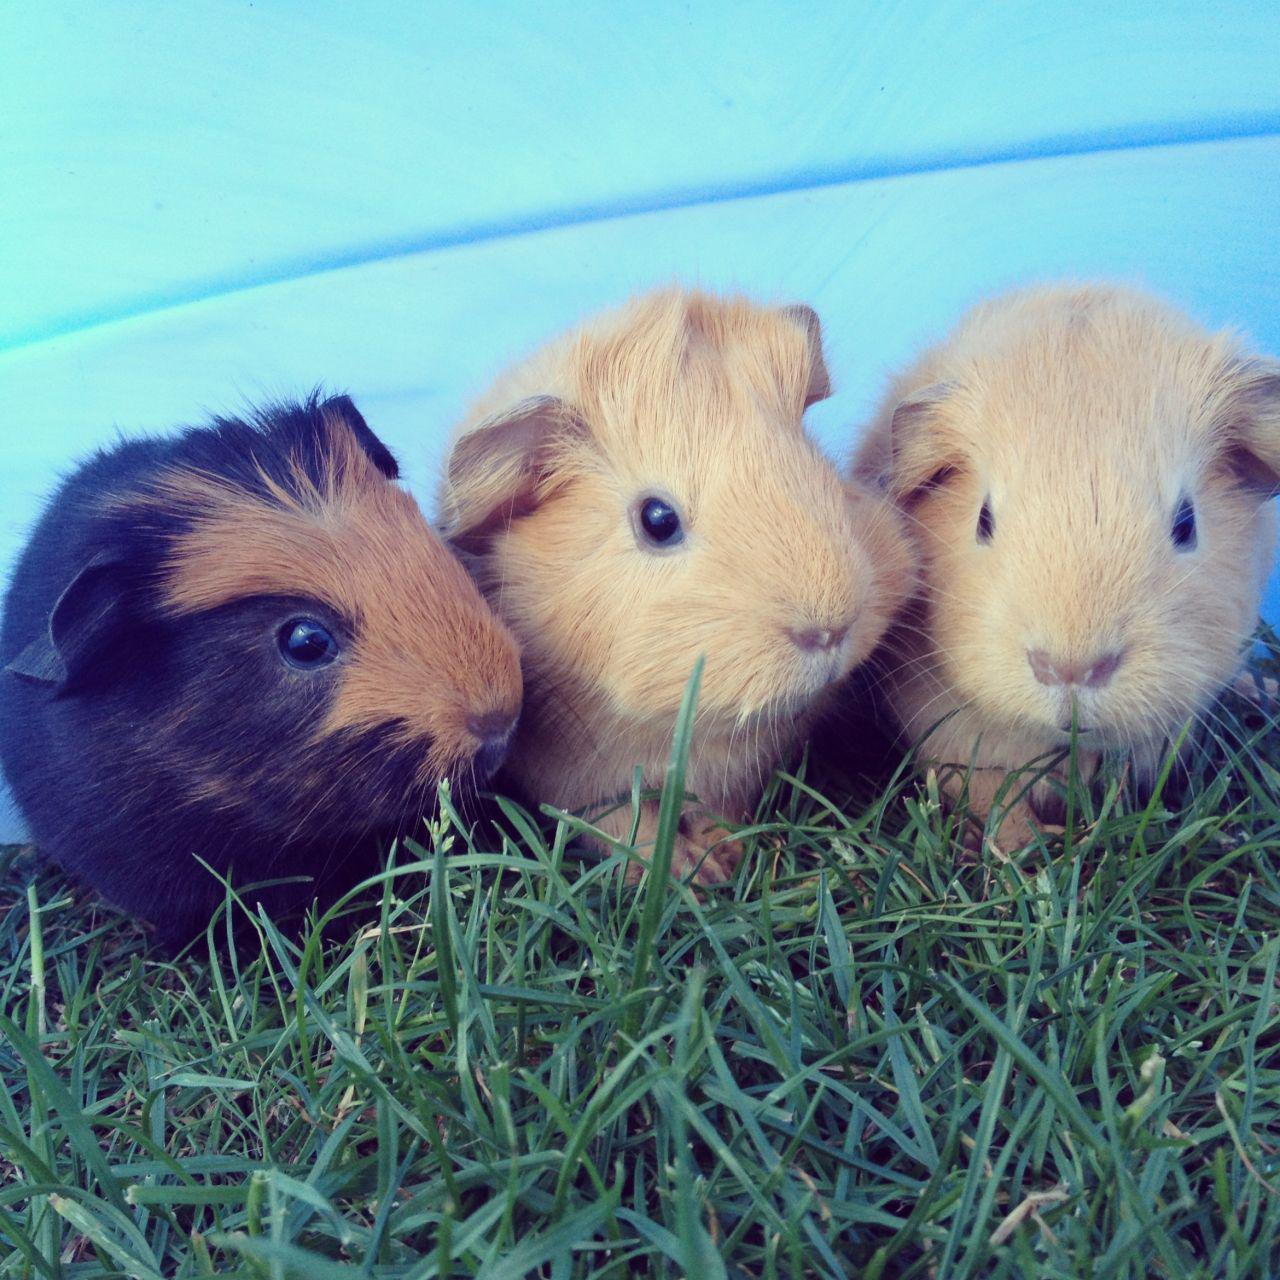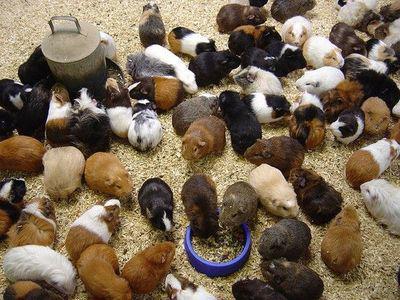The first image is the image on the left, the second image is the image on the right. Analyze the images presented: Is the assertion "There are exactly three rodents in the image on the left." valid? Answer yes or no. Yes. The first image is the image on the left, the second image is the image on the right. For the images shown, is this caption "There are no more than five animals" true? Answer yes or no. No. 